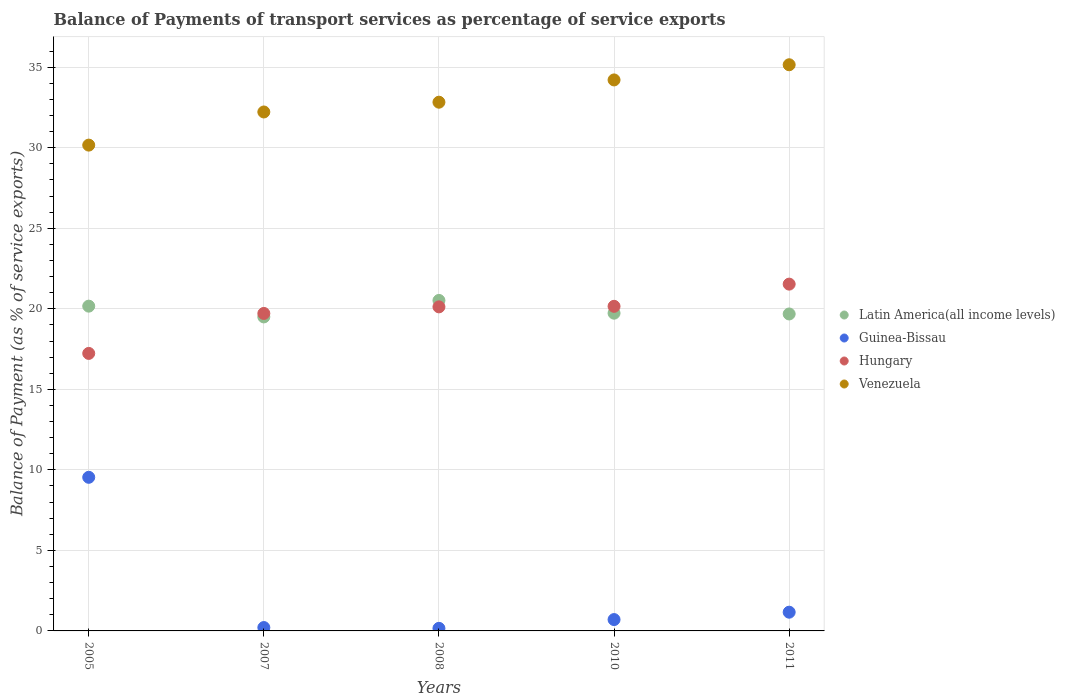How many different coloured dotlines are there?
Keep it short and to the point. 4. What is the balance of payments of transport services in Guinea-Bissau in 2011?
Your answer should be compact. 1.16. Across all years, what is the maximum balance of payments of transport services in Guinea-Bissau?
Provide a short and direct response. 9.54. Across all years, what is the minimum balance of payments of transport services in Latin America(all income levels)?
Offer a very short reply. 19.5. In which year was the balance of payments of transport services in Venezuela maximum?
Ensure brevity in your answer.  2011. In which year was the balance of payments of transport services in Hungary minimum?
Keep it short and to the point. 2005. What is the total balance of payments of transport services in Guinea-Bissau in the graph?
Provide a short and direct response. 11.77. What is the difference between the balance of payments of transport services in Hungary in 2008 and that in 2011?
Keep it short and to the point. -1.41. What is the difference between the balance of payments of transport services in Venezuela in 2005 and the balance of payments of transport services in Latin America(all income levels) in 2008?
Ensure brevity in your answer.  9.64. What is the average balance of payments of transport services in Venezuela per year?
Ensure brevity in your answer.  32.92. In the year 2010, what is the difference between the balance of payments of transport services in Guinea-Bissau and balance of payments of transport services in Venezuela?
Provide a succinct answer. -33.51. In how many years, is the balance of payments of transport services in Venezuela greater than 28 %?
Ensure brevity in your answer.  5. What is the ratio of the balance of payments of transport services in Guinea-Bissau in 2005 to that in 2010?
Your response must be concise. 13.53. Is the balance of payments of transport services in Hungary in 2005 less than that in 2008?
Keep it short and to the point. Yes. Is the difference between the balance of payments of transport services in Guinea-Bissau in 2005 and 2011 greater than the difference between the balance of payments of transport services in Venezuela in 2005 and 2011?
Ensure brevity in your answer.  Yes. What is the difference between the highest and the second highest balance of payments of transport services in Venezuela?
Offer a terse response. 0.94. What is the difference between the highest and the lowest balance of payments of transport services in Venezuela?
Offer a very short reply. 4.99. In how many years, is the balance of payments of transport services in Guinea-Bissau greater than the average balance of payments of transport services in Guinea-Bissau taken over all years?
Give a very brief answer. 1. Is it the case that in every year, the sum of the balance of payments of transport services in Hungary and balance of payments of transport services in Latin America(all income levels)  is greater than the sum of balance of payments of transport services in Venezuela and balance of payments of transport services in Guinea-Bissau?
Your answer should be compact. No. Is the balance of payments of transport services in Venezuela strictly less than the balance of payments of transport services in Guinea-Bissau over the years?
Provide a short and direct response. No. How many dotlines are there?
Offer a terse response. 4. What is the difference between two consecutive major ticks on the Y-axis?
Your answer should be compact. 5. Are the values on the major ticks of Y-axis written in scientific E-notation?
Your answer should be compact. No. Does the graph contain grids?
Ensure brevity in your answer.  Yes. Where does the legend appear in the graph?
Your answer should be compact. Center right. How many legend labels are there?
Give a very brief answer. 4. What is the title of the graph?
Offer a terse response. Balance of Payments of transport services as percentage of service exports. What is the label or title of the Y-axis?
Your answer should be very brief. Balance of Payment (as % of service exports). What is the Balance of Payment (as % of service exports) of Latin America(all income levels) in 2005?
Make the answer very short. 20.17. What is the Balance of Payment (as % of service exports) in Guinea-Bissau in 2005?
Your answer should be very brief. 9.54. What is the Balance of Payment (as % of service exports) of Hungary in 2005?
Your answer should be very brief. 17.23. What is the Balance of Payment (as % of service exports) of Venezuela in 2005?
Your answer should be compact. 30.16. What is the Balance of Payment (as % of service exports) in Latin America(all income levels) in 2007?
Keep it short and to the point. 19.5. What is the Balance of Payment (as % of service exports) in Guinea-Bissau in 2007?
Your answer should be very brief. 0.21. What is the Balance of Payment (as % of service exports) in Hungary in 2007?
Give a very brief answer. 19.71. What is the Balance of Payment (as % of service exports) of Venezuela in 2007?
Offer a very short reply. 32.22. What is the Balance of Payment (as % of service exports) in Latin America(all income levels) in 2008?
Give a very brief answer. 20.52. What is the Balance of Payment (as % of service exports) of Guinea-Bissau in 2008?
Ensure brevity in your answer.  0.16. What is the Balance of Payment (as % of service exports) of Hungary in 2008?
Give a very brief answer. 20.12. What is the Balance of Payment (as % of service exports) of Venezuela in 2008?
Your answer should be compact. 32.83. What is the Balance of Payment (as % of service exports) of Latin America(all income levels) in 2010?
Give a very brief answer. 19.73. What is the Balance of Payment (as % of service exports) in Guinea-Bissau in 2010?
Your response must be concise. 0.7. What is the Balance of Payment (as % of service exports) of Hungary in 2010?
Ensure brevity in your answer.  20.15. What is the Balance of Payment (as % of service exports) of Venezuela in 2010?
Offer a very short reply. 34.21. What is the Balance of Payment (as % of service exports) of Latin America(all income levels) in 2011?
Your response must be concise. 19.68. What is the Balance of Payment (as % of service exports) in Guinea-Bissau in 2011?
Provide a short and direct response. 1.16. What is the Balance of Payment (as % of service exports) in Hungary in 2011?
Provide a short and direct response. 21.53. What is the Balance of Payment (as % of service exports) of Venezuela in 2011?
Provide a short and direct response. 35.15. Across all years, what is the maximum Balance of Payment (as % of service exports) in Latin America(all income levels)?
Offer a very short reply. 20.52. Across all years, what is the maximum Balance of Payment (as % of service exports) of Guinea-Bissau?
Offer a terse response. 9.54. Across all years, what is the maximum Balance of Payment (as % of service exports) in Hungary?
Keep it short and to the point. 21.53. Across all years, what is the maximum Balance of Payment (as % of service exports) in Venezuela?
Offer a very short reply. 35.15. Across all years, what is the minimum Balance of Payment (as % of service exports) in Latin America(all income levels)?
Provide a short and direct response. 19.5. Across all years, what is the minimum Balance of Payment (as % of service exports) in Guinea-Bissau?
Offer a terse response. 0.16. Across all years, what is the minimum Balance of Payment (as % of service exports) of Hungary?
Your response must be concise. 17.23. Across all years, what is the minimum Balance of Payment (as % of service exports) of Venezuela?
Your answer should be compact. 30.16. What is the total Balance of Payment (as % of service exports) in Latin America(all income levels) in the graph?
Provide a succinct answer. 99.59. What is the total Balance of Payment (as % of service exports) of Guinea-Bissau in the graph?
Make the answer very short. 11.77. What is the total Balance of Payment (as % of service exports) of Hungary in the graph?
Make the answer very short. 98.75. What is the total Balance of Payment (as % of service exports) of Venezuela in the graph?
Ensure brevity in your answer.  164.58. What is the difference between the Balance of Payment (as % of service exports) in Latin America(all income levels) in 2005 and that in 2007?
Provide a succinct answer. 0.67. What is the difference between the Balance of Payment (as % of service exports) in Guinea-Bissau in 2005 and that in 2007?
Make the answer very short. 9.33. What is the difference between the Balance of Payment (as % of service exports) in Hungary in 2005 and that in 2007?
Give a very brief answer. -2.48. What is the difference between the Balance of Payment (as % of service exports) of Venezuela in 2005 and that in 2007?
Offer a terse response. -2.06. What is the difference between the Balance of Payment (as % of service exports) of Latin America(all income levels) in 2005 and that in 2008?
Ensure brevity in your answer.  -0.35. What is the difference between the Balance of Payment (as % of service exports) of Guinea-Bissau in 2005 and that in 2008?
Offer a very short reply. 9.38. What is the difference between the Balance of Payment (as % of service exports) of Hungary in 2005 and that in 2008?
Your answer should be compact. -2.89. What is the difference between the Balance of Payment (as % of service exports) in Venezuela in 2005 and that in 2008?
Your answer should be very brief. -2.66. What is the difference between the Balance of Payment (as % of service exports) of Latin America(all income levels) in 2005 and that in 2010?
Offer a very short reply. 0.44. What is the difference between the Balance of Payment (as % of service exports) in Guinea-Bissau in 2005 and that in 2010?
Your response must be concise. 8.83. What is the difference between the Balance of Payment (as % of service exports) in Hungary in 2005 and that in 2010?
Make the answer very short. -2.92. What is the difference between the Balance of Payment (as % of service exports) in Venezuela in 2005 and that in 2010?
Provide a succinct answer. -4.05. What is the difference between the Balance of Payment (as % of service exports) in Latin America(all income levels) in 2005 and that in 2011?
Your answer should be very brief. 0.49. What is the difference between the Balance of Payment (as % of service exports) of Guinea-Bissau in 2005 and that in 2011?
Ensure brevity in your answer.  8.37. What is the difference between the Balance of Payment (as % of service exports) in Hungary in 2005 and that in 2011?
Give a very brief answer. -4.3. What is the difference between the Balance of Payment (as % of service exports) in Venezuela in 2005 and that in 2011?
Offer a terse response. -4.99. What is the difference between the Balance of Payment (as % of service exports) of Latin America(all income levels) in 2007 and that in 2008?
Offer a terse response. -1.02. What is the difference between the Balance of Payment (as % of service exports) in Guinea-Bissau in 2007 and that in 2008?
Keep it short and to the point. 0.05. What is the difference between the Balance of Payment (as % of service exports) of Hungary in 2007 and that in 2008?
Your answer should be compact. -0.41. What is the difference between the Balance of Payment (as % of service exports) in Venezuela in 2007 and that in 2008?
Your response must be concise. -0.61. What is the difference between the Balance of Payment (as % of service exports) of Latin America(all income levels) in 2007 and that in 2010?
Provide a succinct answer. -0.23. What is the difference between the Balance of Payment (as % of service exports) in Guinea-Bissau in 2007 and that in 2010?
Give a very brief answer. -0.5. What is the difference between the Balance of Payment (as % of service exports) of Hungary in 2007 and that in 2010?
Provide a short and direct response. -0.44. What is the difference between the Balance of Payment (as % of service exports) in Venezuela in 2007 and that in 2010?
Your answer should be very brief. -1.99. What is the difference between the Balance of Payment (as % of service exports) of Latin America(all income levels) in 2007 and that in 2011?
Give a very brief answer. -0.18. What is the difference between the Balance of Payment (as % of service exports) of Guinea-Bissau in 2007 and that in 2011?
Keep it short and to the point. -0.95. What is the difference between the Balance of Payment (as % of service exports) in Hungary in 2007 and that in 2011?
Offer a terse response. -1.82. What is the difference between the Balance of Payment (as % of service exports) of Venezuela in 2007 and that in 2011?
Your response must be concise. -2.93. What is the difference between the Balance of Payment (as % of service exports) of Latin America(all income levels) in 2008 and that in 2010?
Your answer should be very brief. 0.79. What is the difference between the Balance of Payment (as % of service exports) of Guinea-Bissau in 2008 and that in 2010?
Provide a short and direct response. -0.54. What is the difference between the Balance of Payment (as % of service exports) in Hungary in 2008 and that in 2010?
Provide a short and direct response. -0.03. What is the difference between the Balance of Payment (as % of service exports) in Venezuela in 2008 and that in 2010?
Offer a terse response. -1.38. What is the difference between the Balance of Payment (as % of service exports) in Latin America(all income levels) in 2008 and that in 2011?
Keep it short and to the point. 0.84. What is the difference between the Balance of Payment (as % of service exports) in Guinea-Bissau in 2008 and that in 2011?
Your response must be concise. -1. What is the difference between the Balance of Payment (as % of service exports) in Hungary in 2008 and that in 2011?
Give a very brief answer. -1.41. What is the difference between the Balance of Payment (as % of service exports) in Venezuela in 2008 and that in 2011?
Your response must be concise. -2.33. What is the difference between the Balance of Payment (as % of service exports) of Latin America(all income levels) in 2010 and that in 2011?
Your answer should be compact. 0.05. What is the difference between the Balance of Payment (as % of service exports) of Guinea-Bissau in 2010 and that in 2011?
Your answer should be compact. -0.46. What is the difference between the Balance of Payment (as % of service exports) of Hungary in 2010 and that in 2011?
Give a very brief answer. -1.38. What is the difference between the Balance of Payment (as % of service exports) in Venezuela in 2010 and that in 2011?
Ensure brevity in your answer.  -0.94. What is the difference between the Balance of Payment (as % of service exports) in Latin America(all income levels) in 2005 and the Balance of Payment (as % of service exports) in Guinea-Bissau in 2007?
Make the answer very short. 19.96. What is the difference between the Balance of Payment (as % of service exports) of Latin America(all income levels) in 2005 and the Balance of Payment (as % of service exports) of Hungary in 2007?
Keep it short and to the point. 0.45. What is the difference between the Balance of Payment (as % of service exports) in Latin America(all income levels) in 2005 and the Balance of Payment (as % of service exports) in Venezuela in 2007?
Make the answer very short. -12.06. What is the difference between the Balance of Payment (as % of service exports) in Guinea-Bissau in 2005 and the Balance of Payment (as % of service exports) in Hungary in 2007?
Make the answer very short. -10.17. What is the difference between the Balance of Payment (as % of service exports) of Guinea-Bissau in 2005 and the Balance of Payment (as % of service exports) of Venezuela in 2007?
Your response must be concise. -22.68. What is the difference between the Balance of Payment (as % of service exports) in Hungary in 2005 and the Balance of Payment (as % of service exports) in Venezuela in 2007?
Keep it short and to the point. -14.99. What is the difference between the Balance of Payment (as % of service exports) of Latin America(all income levels) in 2005 and the Balance of Payment (as % of service exports) of Guinea-Bissau in 2008?
Give a very brief answer. 20.01. What is the difference between the Balance of Payment (as % of service exports) in Latin America(all income levels) in 2005 and the Balance of Payment (as % of service exports) in Hungary in 2008?
Make the answer very short. 0.04. What is the difference between the Balance of Payment (as % of service exports) in Latin America(all income levels) in 2005 and the Balance of Payment (as % of service exports) in Venezuela in 2008?
Make the answer very short. -12.66. What is the difference between the Balance of Payment (as % of service exports) of Guinea-Bissau in 2005 and the Balance of Payment (as % of service exports) of Hungary in 2008?
Your answer should be compact. -10.58. What is the difference between the Balance of Payment (as % of service exports) in Guinea-Bissau in 2005 and the Balance of Payment (as % of service exports) in Venezuela in 2008?
Ensure brevity in your answer.  -23.29. What is the difference between the Balance of Payment (as % of service exports) in Hungary in 2005 and the Balance of Payment (as % of service exports) in Venezuela in 2008?
Make the answer very short. -15.6. What is the difference between the Balance of Payment (as % of service exports) of Latin America(all income levels) in 2005 and the Balance of Payment (as % of service exports) of Guinea-Bissau in 2010?
Keep it short and to the point. 19.46. What is the difference between the Balance of Payment (as % of service exports) of Latin America(all income levels) in 2005 and the Balance of Payment (as % of service exports) of Hungary in 2010?
Provide a short and direct response. 0.01. What is the difference between the Balance of Payment (as % of service exports) of Latin America(all income levels) in 2005 and the Balance of Payment (as % of service exports) of Venezuela in 2010?
Offer a terse response. -14.05. What is the difference between the Balance of Payment (as % of service exports) of Guinea-Bissau in 2005 and the Balance of Payment (as % of service exports) of Hungary in 2010?
Your answer should be compact. -10.62. What is the difference between the Balance of Payment (as % of service exports) in Guinea-Bissau in 2005 and the Balance of Payment (as % of service exports) in Venezuela in 2010?
Keep it short and to the point. -24.67. What is the difference between the Balance of Payment (as % of service exports) in Hungary in 2005 and the Balance of Payment (as % of service exports) in Venezuela in 2010?
Offer a very short reply. -16.98. What is the difference between the Balance of Payment (as % of service exports) of Latin America(all income levels) in 2005 and the Balance of Payment (as % of service exports) of Guinea-Bissau in 2011?
Provide a short and direct response. 19. What is the difference between the Balance of Payment (as % of service exports) of Latin America(all income levels) in 2005 and the Balance of Payment (as % of service exports) of Hungary in 2011?
Provide a succinct answer. -1.37. What is the difference between the Balance of Payment (as % of service exports) of Latin America(all income levels) in 2005 and the Balance of Payment (as % of service exports) of Venezuela in 2011?
Offer a terse response. -14.99. What is the difference between the Balance of Payment (as % of service exports) in Guinea-Bissau in 2005 and the Balance of Payment (as % of service exports) in Hungary in 2011?
Offer a terse response. -11.99. What is the difference between the Balance of Payment (as % of service exports) in Guinea-Bissau in 2005 and the Balance of Payment (as % of service exports) in Venezuela in 2011?
Keep it short and to the point. -25.61. What is the difference between the Balance of Payment (as % of service exports) in Hungary in 2005 and the Balance of Payment (as % of service exports) in Venezuela in 2011?
Provide a short and direct response. -17.92. What is the difference between the Balance of Payment (as % of service exports) of Latin America(all income levels) in 2007 and the Balance of Payment (as % of service exports) of Guinea-Bissau in 2008?
Offer a very short reply. 19.34. What is the difference between the Balance of Payment (as % of service exports) of Latin America(all income levels) in 2007 and the Balance of Payment (as % of service exports) of Hungary in 2008?
Provide a succinct answer. -0.62. What is the difference between the Balance of Payment (as % of service exports) in Latin America(all income levels) in 2007 and the Balance of Payment (as % of service exports) in Venezuela in 2008?
Keep it short and to the point. -13.33. What is the difference between the Balance of Payment (as % of service exports) of Guinea-Bissau in 2007 and the Balance of Payment (as % of service exports) of Hungary in 2008?
Ensure brevity in your answer.  -19.91. What is the difference between the Balance of Payment (as % of service exports) in Guinea-Bissau in 2007 and the Balance of Payment (as % of service exports) in Venezuela in 2008?
Make the answer very short. -32.62. What is the difference between the Balance of Payment (as % of service exports) of Hungary in 2007 and the Balance of Payment (as % of service exports) of Venezuela in 2008?
Keep it short and to the point. -13.12. What is the difference between the Balance of Payment (as % of service exports) of Latin America(all income levels) in 2007 and the Balance of Payment (as % of service exports) of Guinea-Bissau in 2010?
Give a very brief answer. 18.79. What is the difference between the Balance of Payment (as % of service exports) of Latin America(all income levels) in 2007 and the Balance of Payment (as % of service exports) of Hungary in 2010?
Provide a succinct answer. -0.66. What is the difference between the Balance of Payment (as % of service exports) in Latin America(all income levels) in 2007 and the Balance of Payment (as % of service exports) in Venezuela in 2010?
Your answer should be very brief. -14.71. What is the difference between the Balance of Payment (as % of service exports) in Guinea-Bissau in 2007 and the Balance of Payment (as % of service exports) in Hungary in 2010?
Keep it short and to the point. -19.94. What is the difference between the Balance of Payment (as % of service exports) in Guinea-Bissau in 2007 and the Balance of Payment (as % of service exports) in Venezuela in 2010?
Provide a succinct answer. -34. What is the difference between the Balance of Payment (as % of service exports) of Hungary in 2007 and the Balance of Payment (as % of service exports) of Venezuela in 2010?
Your answer should be compact. -14.5. What is the difference between the Balance of Payment (as % of service exports) in Latin America(all income levels) in 2007 and the Balance of Payment (as % of service exports) in Guinea-Bissau in 2011?
Offer a terse response. 18.33. What is the difference between the Balance of Payment (as % of service exports) of Latin America(all income levels) in 2007 and the Balance of Payment (as % of service exports) of Hungary in 2011?
Make the answer very short. -2.04. What is the difference between the Balance of Payment (as % of service exports) of Latin America(all income levels) in 2007 and the Balance of Payment (as % of service exports) of Venezuela in 2011?
Offer a very short reply. -15.66. What is the difference between the Balance of Payment (as % of service exports) of Guinea-Bissau in 2007 and the Balance of Payment (as % of service exports) of Hungary in 2011?
Make the answer very short. -21.32. What is the difference between the Balance of Payment (as % of service exports) of Guinea-Bissau in 2007 and the Balance of Payment (as % of service exports) of Venezuela in 2011?
Make the answer very short. -34.94. What is the difference between the Balance of Payment (as % of service exports) in Hungary in 2007 and the Balance of Payment (as % of service exports) in Venezuela in 2011?
Make the answer very short. -15.44. What is the difference between the Balance of Payment (as % of service exports) in Latin America(all income levels) in 2008 and the Balance of Payment (as % of service exports) in Guinea-Bissau in 2010?
Offer a terse response. 19.81. What is the difference between the Balance of Payment (as % of service exports) in Latin America(all income levels) in 2008 and the Balance of Payment (as % of service exports) in Hungary in 2010?
Provide a succinct answer. 0.37. What is the difference between the Balance of Payment (as % of service exports) of Latin America(all income levels) in 2008 and the Balance of Payment (as % of service exports) of Venezuela in 2010?
Keep it short and to the point. -13.69. What is the difference between the Balance of Payment (as % of service exports) of Guinea-Bissau in 2008 and the Balance of Payment (as % of service exports) of Hungary in 2010?
Keep it short and to the point. -19.99. What is the difference between the Balance of Payment (as % of service exports) in Guinea-Bissau in 2008 and the Balance of Payment (as % of service exports) in Venezuela in 2010?
Ensure brevity in your answer.  -34.05. What is the difference between the Balance of Payment (as % of service exports) in Hungary in 2008 and the Balance of Payment (as % of service exports) in Venezuela in 2010?
Provide a short and direct response. -14.09. What is the difference between the Balance of Payment (as % of service exports) of Latin America(all income levels) in 2008 and the Balance of Payment (as % of service exports) of Guinea-Bissau in 2011?
Offer a very short reply. 19.36. What is the difference between the Balance of Payment (as % of service exports) of Latin America(all income levels) in 2008 and the Balance of Payment (as % of service exports) of Hungary in 2011?
Provide a short and direct response. -1.01. What is the difference between the Balance of Payment (as % of service exports) in Latin America(all income levels) in 2008 and the Balance of Payment (as % of service exports) in Venezuela in 2011?
Give a very brief answer. -14.63. What is the difference between the Balance of Payment (as % of service exports) in Guinea-Bissau in 2008 and the Balance of Payment (as % of service exports) in Hungary in 2011?
Provide a short and direct response. -21.37. What is the difference between the Balance of Payment (as % of service exports) in Guinea-Bissau in 2008 and the Balance of Payment (as % of service exports) in Venezuela in 2011?
Your answer should be very brief. -34.99. What is the difference between the Balance of Payment (as % of service exports) of Hungary in 2008 and the Balance of Payment (as % of service exports) of Venezuela in 2011?
Ensure brevity in your answer.  -15.03. What is the difference between the Balance of Payment (as % of service exports) of Latin America(all income levels) in 2010 and the Balance of Payment (as % of service exports) of Guinea-Bissau in 2011?
Make the answer very short. 18.56. What is the difference between the Balance of Payment (as % of service exports) in Latin America(all income levels) in 2010 and the Balance of Payment (as % of service exports) in Hungary in 2011?
Give a very brief answer. -1.8. What is the difference between the Balance of Payment (as % of service exports) of Latin America(all income levels) in 2010 and the Balance of Payment (as % of service exports) of Venezuela in 2011?
Your response must be concise. -15.43. What is the difference between the Balance of Payment (as % of service exports) in Guinea-Bissau in 2010 and the Balance of Payment (as % of service exports) in Hungary in 2011?
Your response must be concise. -20.83. What is the difference between the Balance of Payment (as % of service exports) of Guinea-Bissau in 2010 and the Balance of Payment (as % of service exports) of Venezuela in 2011?
Keep it short and to the point. -34.45. What is the difference between the Balance of Payment (as % of service exports) of Hungary in 2010 and the Balance of Payment (as % of service exports) of Venezuela in 2011?
Offer a very short reply. -15. What is the average Balance of Payment (as % of service exports) in Latin America(all income levels) per year?
Your answer should be very brief. 19.92. What is the average Balance of Payment (as % of service exports) of Guinea-Bissau per year?
Your response must be concise. 2.35. What is the average Balance of Payment (as % of service exports) of Hungary per year?
Your answer should be compact. 19.75. What is the average Balance of Payment (as % of service exports) of Venezuela per year?
Give a very brief answer. 32.92. In the year 2005, what is the difference between the Balance of Payment (as % of service exports) of Latin America(all income levels) and Balance of Payment (as % of service exports) of Guinea-Bissau?
Provide a short and direct response. 10.63. In the year 2005, what is the difference between the Balance of Payment (as % of service exports) of Latin America(all income levels) and Balance of Payment (as % of service exports) of Hungary?
Your answer should be very brief. 2.93. In the year 2005, what is the difference between the Balance of Payment (as % of service exports) of Latin America(all income levels) and Balance of Payment (as % of service exports) of Venezuela?
Make the answer very short. -10. In the year 2005, what is the difference between the Balance of Payment (as % of service exports) of Guinea-Bissau and Balance of Payment (as % of service exports) of Hungary?
Your answer should be compact. -7.69. In the year 2005, what is the difference between the Balance of Payment (as % of service exports) of Guinea-Bissau and Balance of Payment (as % of service exports) of Venezuela?
Keep it short and to the point. -20.63. In the year 2005, what is the difference between the Balance of Payment (as % of service exports) of Hungary and Balance of Payment (as % of service exports) of Venezuela?
Provide a short and direct response. -12.93. In the year 2007, what is the difference between the Balance of Payment (as % of service exports) in Latin America(all income levels) and Balance of Payment (as % of service exports) in Guinea-Bissau?
Your response must be concise. 19.29. In the year 2007, what is the difference between the Balance of Payment (as % of service exports) in Latin America(all income levels) and Balance of Payment (as % of service exports) in Hungary?
Offer a very short reply. -0.22. In the year 2007, what is the difference between the Balance of Payment (as % of service exports) in Latin America(all income levels) and Balance of Payment (as % of service exports) in Venezuela?
Give a very brief answer. -12.72. In the year 2007, what is the difference between the Balance of Payment (as % of service exports) in Guinea-Bissau and Balance of Payment (as % of service exports) in Hungary?
Offer a very short reply. -19.5. In the year 2007, what is the difference between the Balance of Payment (as % of service exports) in Guinea-Bissau and Balance of Payment (as % of service exports) in Venezuela?
Your answer should be very brief. -32.01. In the year 2007, what is the difference between the Balance of Payment (as % of service exports) in Hungary and Balance of Payment (as % of service exports) in Venezuela?
Keep it short and to the point. -12.51. In the year 2008, what is the difference between the Balance of Payment (as % of service exports) of Latin America(all income levels) and Balance of Payment (as % of service exports) of Guinea-Bissau?
Make the answer very short. 20.36. In the year 2008, what is the difference between the Balance of Payment (as % of service exports) in Latin America(all income levels) and Balance of Payment (as % of service exports) in Hungary?
Ensure brevity in your answer.  0.4. In the year 2008, what is the difference between the Balance of Payment (as % of service exports) in Latin America(all income levels) and Balance of Payment (as % of service exports) in Venezuela?
Your response must be concise. -12.31. In the year 2008, what is the difference between the Balance of Payment (as % of service exports) in Guinea-Bissau and Balance of Payment (as % of service exports) in Hungary?
Offer a very short reply. -19.96. In the year 2008, what is the difference between the Balance of Payment (as % of service exports) in Guinea-Bissau and Balance of Payment (as % of service exports) in Venezuela?
Make the answer very short. -32.67. In the year 2008, what is the difference between the Balance of Payment (as % of service exports) in Hungary and Balance of Payment (as % of service exports) in Venezuela?
Provide a short and direct response. -12.71. In the year 2010, what is the difference between the Balance of Payment (as % of service exports) in Latin America(all income levels) and Balance of Payment (as % of service exports) in Guinea-Bissau?
Make the answer very short. 19.02. In the year 2010, what is the difference between the Balance of Payment (as % of service exports) in Latin America(all income levels) and Balance of Payment (as % of service exports) in Hungary?
Give a very brief answer. -0.43. In the year 2010, what is the difference between the Balance of Payment (as % of service exports) in Latin America(all income levels) and Balance of Payment (as % of service exports) in Venezuela?
Provide a short and direct response. -14.48. In the year 2010, what is the difference between the Balance of Payment (as % of service exports) of Guinea-Bissau and Balance of Payment (as % of service exports) of Hungary?
Give a very brief answer. -19.45. In the year 2010, what is the difference between the Balance of Payment (as % of service exports) of Guinea-Bissau and Balance of Payment (as % of service exports) of Venezuela?
Ensure brevity in your answer.  -33.51. In the year 2010, what is the difference between the Balance of Payment (as % of service exports) of Hungary and Balance of Payment (as % of service exports) of Venezuela?
Your response must be concise. -14.06. In the year 2011, what is the difference between the Balance of Payment (as % of service exports) in Latin America(all income levels) and Balance of Payment (as % of service exports) in Guinea-Bissau?
Ensure brevity in your answer.  18.52. In the year 2011, what is the difference between the Balance of Payment (as % of service exports) in Latin America(all income levels) and Balance of Payment (as % of service exports) in Hungary?
Your answer should be very brief. -1.85. In the year 2011, what is the difference between the Balance of Payment (as % of service exports) in Latin America(all income levels) and Balance of Payment (as % of service exports) in Venezuela?
Ensure brevity in your answer.  -15.47. In the year 2011, what is the difference between the Balance of Payment (as % of service exports) of Guinea-Bissau and Balance of Payment (as % of service exports) of Hungary?
Ensure brevity in your answer.  -20.37. In the year 2011, what is the difference between the Balance of Payment (as % of service exports) in Guinea-Bissau and Balance of Payment (as % of service exports) in Venezuela?
Offer a very short reply. -33.99. In the year 2011, what is the difference between the Balance of Payment (as % of service exports) of Hungary and Balance of Payment (as % of service exports) of Venezuela?
Your answer should be very brief. -13.62. What is the ratio of the Balance of Payment (as % of service exports) in Latin America(all income levels) in 2005 to that in 2007?
Keep it short and to the point. 1.03. What is the ratio of the Balance of Payment (as % of service exports) of Guinea-Bissau in 2005 to that in 2007?
Make the answer very short. 45.5. What is the ratio of the Balance of Payment (as % of service exports) in Hungary in 2005 to that in 2007?
Your answer should be compact. 0.87. What is the ratio of the Balance of Payment (as % of service exports) of Venezuela in 2005 to that in 2007?
Ensure brevity in your answer.  0.94. What is the ratio of the Balance of Payment (as % of service exports) in Latin America(all income levels) in 2005 to that in 2008?
Offer a terse response. 0.98. What is the ratio of the Balance of Payment (as % of service exports) in Guinea-Bissau in 2005 to that in 2008?
Make the answer very short. 59.64. What is the ratio of the Balance of Payment (as % of service exports) in Hungary in 2005 to that in 2008?
Your answer should be compact. 0.86. What is the ratio of the Balance of Payment (as % of service exports) of Venezuela in 2005 to that in 2008?
Offer a terse response. 0.92. What is the ratio of the Balance of Payment (as % of service exports) in Latin America(all income levels) in 2005 to that in 2010?
Provide a short and direct response. 1.02. What is the ratio of the Balance of Payment (as % of service exports) in Guinea-Bissau in 2005 to that in 2010?
Offer a terse response. 13.53. What is the ratio of the Balance of Payment (as % of service exports) in Hungary in 2005 to that in 2010?
Ensure brevity in your answer.  0.85. What is the ratio of the Balance of Payment (as % of service exports) of Venezuela in 2005 to that in 2010?
Ensure brevity in your answer.  0.88. What is the ratio of the Balance of Payment (as % of service exports) of Latin America(all income levels) in 2005 to that in 2011?
Give a very brief answer. 1.02. What is the ratio of the Balance of Payment (as % of service exports) in Guinea-Bissau in 2005 to that in 2011?
Give a very brief answer. 8.2. What is the ratio of the Balance of Payment (as % of service exports) of Hungary in 2005 to that in 2011?
Offer a very short reply. 0.8. What is the ratio of the Balance of Payment (as % of service exports) in Venezuela in 2005 to that in 2011?
Offer a terse response. 0.86. What is the ratio of the Balance of Payment (as % of service exports) in Latin America(all income levels) in 2007 to that in 2008?
Keep it short and to the point. 0.95. What is the ratio of the Balance of Payment (as % of service exports) in Guinea-Bissau in 2007 to that in 2008?
Your answer should be very brief. 1.31. What is the ratio of the Balance of Payment (as % of service exports) of Hungary in 2007 to that in 2008?
Offer a terse response. 0.98. What is the ratio of the Balance of Payment (as % of service exports) of Venezuela in 2007 to that in 2008?
Make the answer very short. 0.98. What is the ratio of the Balance of Payment (as % of service exports) in Latin America(all income levels) in 2007 to that in 2010?
Provide a succinct answer. 0.99. What is the ratio of the Balance of Payment (as % of service exports) in Guinea-Bissau in 2007 to that in 2010?
Offer a terse response. 0.3. What is the ratio of the Balance of Payment (as % of service exports) in Hungary in 2007 to that in 2010?
Offer a very short reply. 0.98. What is the ratio of the Balance of Payment (as % of service exports) in Venezuela in 2007 to that in 2010?
Give a very brief answer. 0.94. What is the ratio of the Balance of Payment (as % of service exports) of Latin America(all income levels) in 2007 to that in 2011?
Your answer should be compact. 0.99. What is the ratio of the Balance of Payment (as % of service exports) of Guinea-Bissau in 2007 to that in 2011?
Your answer should be compact. 0.18. What is the ratio of the Balance of Payment (as % of service exports) of Hungary in 2007 to that in 2011?
Offer a terse response. 0.92. What is the ratio of the Balance of Payment (as % of service exports) of Venezuela in 2007 to that in 2011?
Your answer should be very brief. 0.92. What is the ratio of the Balance of Payment (as % of service exports) of Latin America(all income levels) in 2008 to that in 2010?
Offer a very short reply. 1.04. What is the ratio of the Balance of Payment (as % of service exports) of Guinea-Bissau in 2008 to that in 2010?
Provide a short and direct response. 0.23. What is the ratio of the Balance of Payment (as % of service exports) of Hungary in 2008 to that in 2010?
Offer a very short reply. 1. What is the ratio of the Balance of Payment (as % of service exports) in Venezuela in 2008 to that in 2010?
Keep it short and to the point. 0.96. What is the ratio of the Balance of Payment (as % of service exports) of Latin America(all income levels) in 2008 to that in 2011?
Your answer should be very brief. 1.04. What is the ratio of the Balance of Payment (as % of service exports) of Guinea-Bissau in 2008 to that in 2011?
Provide a short and direct response. 0.14. What is the ratio of the Balance of Payment (as % of service exports) in Hungary in 2008 to that in 2011?
Offer a very short reply. 0.93. What is the ratio of the Balance of Payment (as % of service exports) of Venezuela in 2008 to that in 2011?
Provide a succinct answer. 0.93. What is the ratio of the Balance of Payment (as % of service exports) in Latin America(all income levels) in 2010 to that in 2011?
Provide a succinct answer. 1. What is the ratio of the Balance of Payment (as % of service exports) of Guinea-Bissau in 2010 to that in 2011?
Make the answer very short. 0.61. What is the ratio of the Balance of Payment (as % of service exports) of Hungary in 2010 to that in 2011?
Make the answer very short. 0.94. What is the ratio of the Balance of Payment (as % of service exports) in Venezuela in 2010 to that in 2011?
Keep it short and to the point. 0.97. What is the difference between the highest and the second highest Balance of Payment (as % of service exports) of Latin America(all income levels)?
Provide a short and direct response. 0.35. What is the difference between the highest and the second highest Balance of Payment (as % of service exports) in Guinea-Bissau?
Ensure brevity in your answer.  8.37. What is the difference between the highest and the second highest Balance of Payment (as % of service exports) of Hungary?
Keep it short and to the point. 1.38. What is the difference between the highest and the second highest Balance of Payment (as % of service exports) in Venezuela?
Your answer should be compact. 0.94. What is the difference between the highest and the lowest Balance of Payment (as % of service exports) in Latin America(all income levels)?
Keep it short and to the point. 1.02. What is the difference between the highest and the lowest Balance of Payment (as % of service exports) of Guinea-Bissau?
Provide a succinct answer. 9.38. What is the difference between the highest and the lowest Balance of Payment (as % of service exports) in Hungary?
Your response must be concise. 4.3. What is the difference between the highest and the lowest Balance of Payment (as % of service exports) in Venezuela?
Your response must be concise. 4.99. 